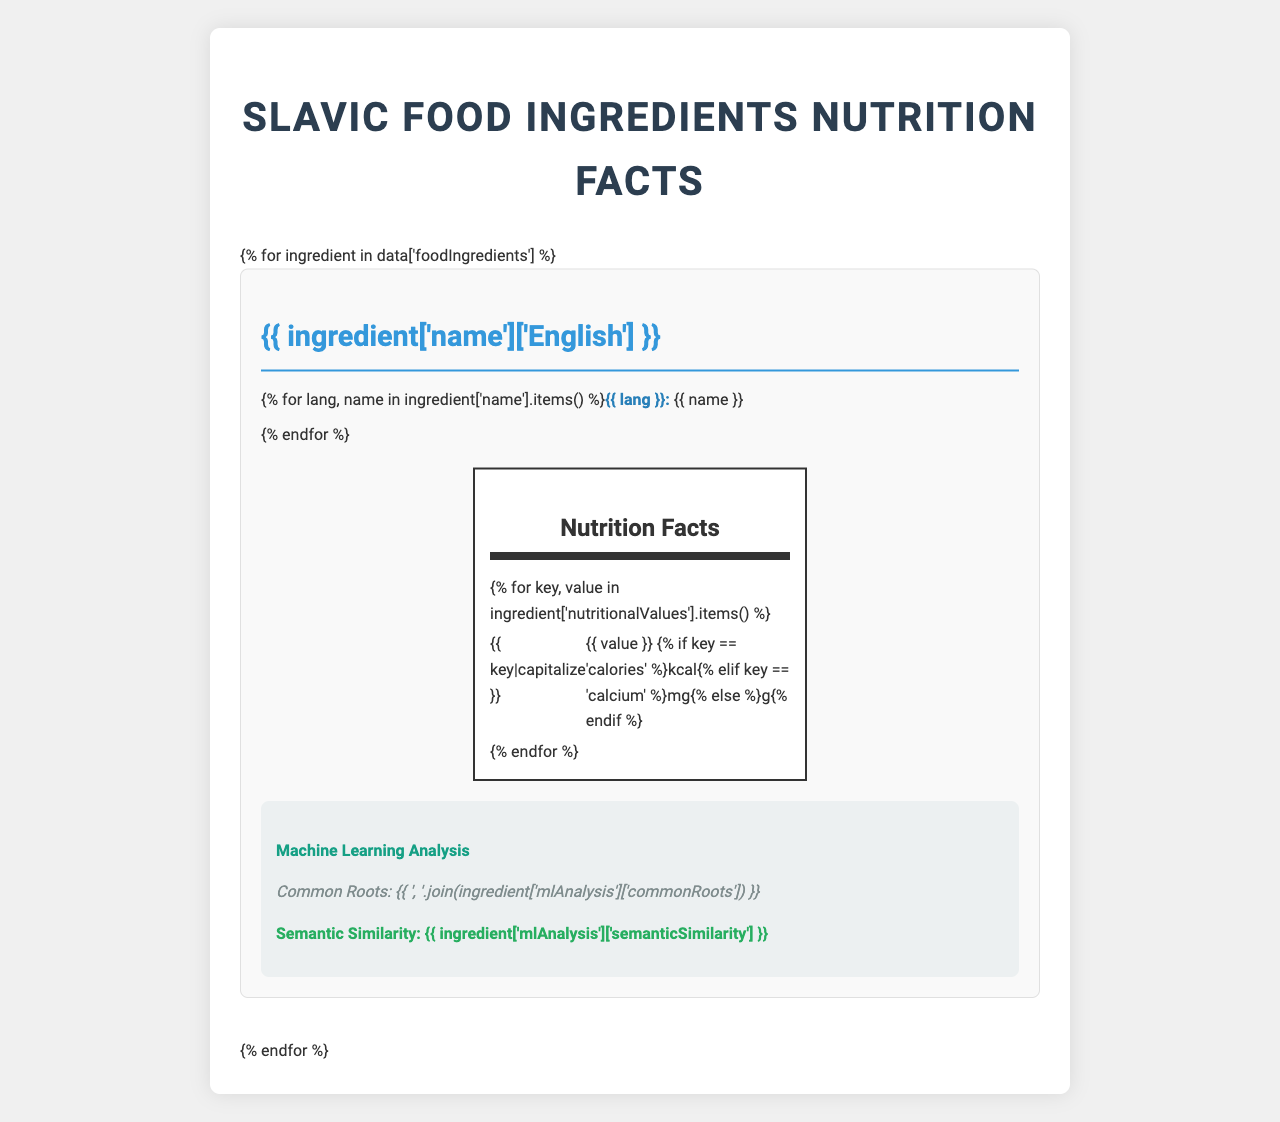What is the protein content in grits ("Гречневая крупа")? The protein content for "Гречневая крупа" (grits) is listed in the nutrition facts as 13.2 grams.
Answer: 13.2 g How many calories are in "Творог" (curd)? The calorie content for "Творог" (curd) is given as 98 kcal in the document.
Answer: 98 kcal What is the common root found in the names of beets across the Slavic languages in the document? The machine learning analysis section for beets lists the common roots across the Slavic languages as "svek", "bur", and "cvek".
Answer: svek, bur, cvek Which ingredient has the highest semantic similarity across the languages? The semantic similarity for "Гречневая крупа" is 0.92, which is the highest among the listed ingredients.
Answer: Гречневая крупа What is the fiber content of "Свекла" (beet)? The fiber content for "Свекла" (beet) is given as 2.8 grams in the nutrition facts section.
Answer: 2.8 g Which of the following Slavic languages is not mentioned in the document?
A. Bulgarian
B. Polish
C. Russian
D. Serbian The document lists "Russian", "Polish", "Czech", "Serbian", and "Ukrainian" as the Slavic languages, but not "Bulgarian".
Answer: A. Bulgarian Which of the following ingredients has the highest protein content?
I. Гречневая крупа
II. Творог
III. Свекла "Творог" (curd) has a protein content of 16.7 grams, which is higher than the protein content of "Гречневая крупа" (13.2g) and "Свекла" (1.6g).
Answer: II. Творог Are soluble fiber and insoluble fiber included in the document's mandatory elements for the Nutrition Facts Label Structure? Soluble fiber and insoluble fiber are listed as optional elements for the Nutrition Facts Label Structure, not mandatory elements.
Answer: No Summarize the main idea of the document. The document summarizes the linguistic analysis and nutritional details of food ingredients across different Slavic languages, presenting translated names, nutritional values, common linguistic features, and discusses the application of machine learning in this context.
Answer: The document provides a comparison of various food ingredients' names, nutritional values, and machine learning analysis across different Slavic languages. It includes translated ingredient names and nutritional facts for each ingredient, as well as highlighting common linguistic roots and semantic similarities. Additionally, it discusses the structure of nutrition facts labels and challenges in applying machine learning techniques to analyze food ingredient names in Slavic languages. What are the recommended intake levels of carbohydrates for adults? The document does not provide information on recommended intake levels of carbohydrates for adults.
Answer: Cannot be determined 